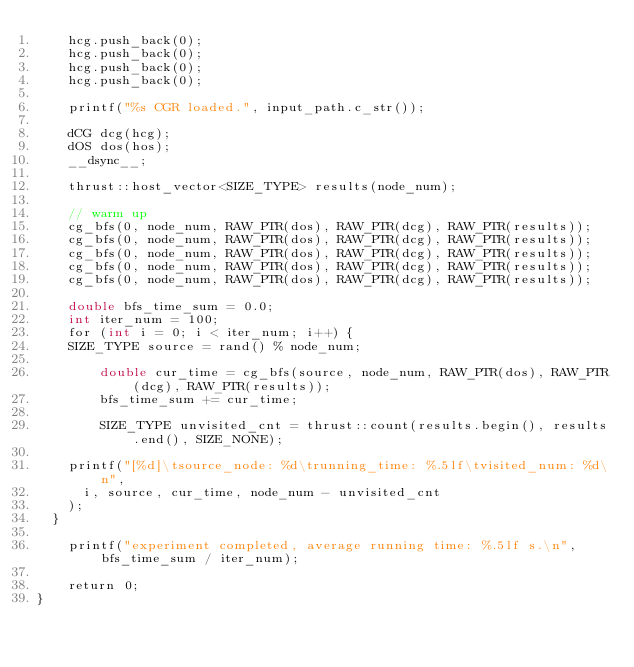Convert code to text. <code><loc_0><loc_0><loc_500><loc_500><_Cuda_>    hcg.push_back(0);
    hcg.push_back(0);
    hcg.push_back(0);
    hcg.push_back(0);

    printf("%s CGR loaded.", input_path.c_str());

    dCG dcg(hcg);
    dOS dos(hos);
    __dsync__;

    thrust::host_vector<SIZE_TYPE> results(node_num);

    // warm up
    cg_bfs(0, node_num, RAW_PTR(dos), RAW_PTR(dcg), RAW_PTR(results));
    cg_bfs(0, node_num, RAW_PTR(dos), RAW_PTR(dcg), RAW_PTR(results));
    cg_bfs(0, node_num, RAW_PTR(dos), RAW_PTR(dcg), RAW_PTR(results));
    cg_bfs(0, node_num, RAW_PTR(dos), RAW_PTR(dcg), RAW_PTR(results));
    cg_bfs(0, node_num, RAW_PTR(dos), RAW_PTR(dcg), RAW_PTR(results));

    double bfs_time_sum = 0.0;
    int iter_num = 100;
    for (int i = 0; i < iter_num; i++) {
		SIZE_TYPE source = rand() % node_num;

        double cur_time = cg_bfs(source, node_num, RAW_PTR(dos), RAW_PTR(dcg), RAW_PTR(results));
        bfs_time_sum += cur_time;

        SIZE_TYPE unvisited_cnt = thrust::count(results.begin(), results.end(), SIZE_NONE);
		
		printf("[%d]\tsource_node: %d\trunning_time: %.5lf\tvisited_num: %d\n",
			i, source, cur_time, node_num - unvisited_cnt
		);
	}
	
    printf("experiment completed, average running time: %.5lf s.\n", bfs_time_sum / iter_num);

    return 0;
}
</code> 